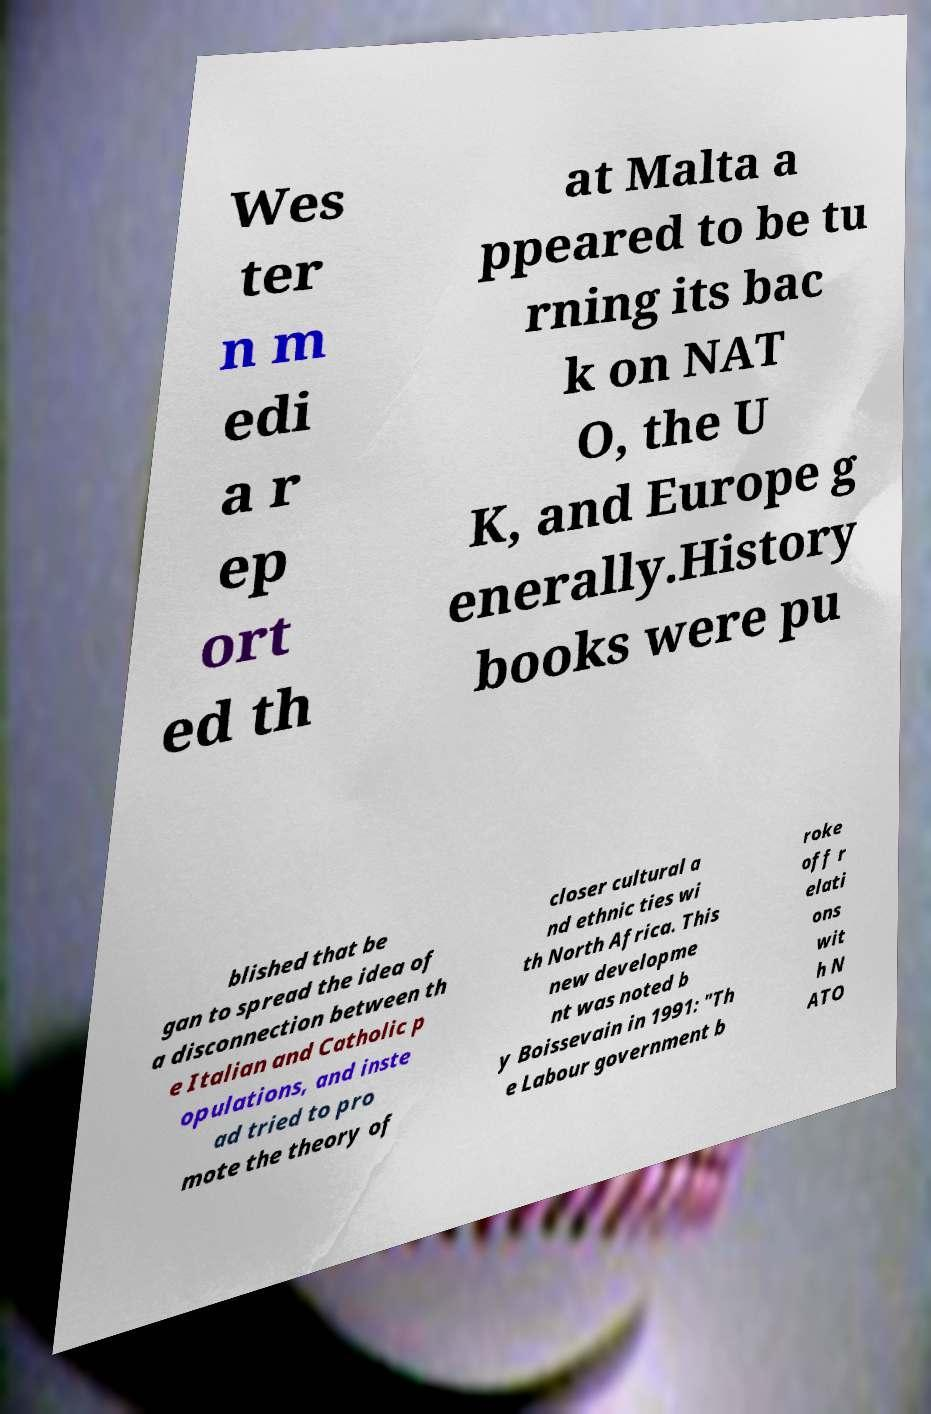Can you accurately transcribe the text from the provided image for me? Wes ter n m edi a r ep ort ed th at Malta a ppeared to be tu rning its bac k on NAT O, the U K, and Europe g enerally.History books were pu blished that be gan to spread the idea of a disconnection between th e Italian and Catholic p opulations, and inste ad tried to pro mote the theory of closer cultural a nd ethnic ties wi th North Africa. This new developme nt was noted b y Boissevain in 1991: "Th e Labour government b roke off r elati ons wit h N ATO 